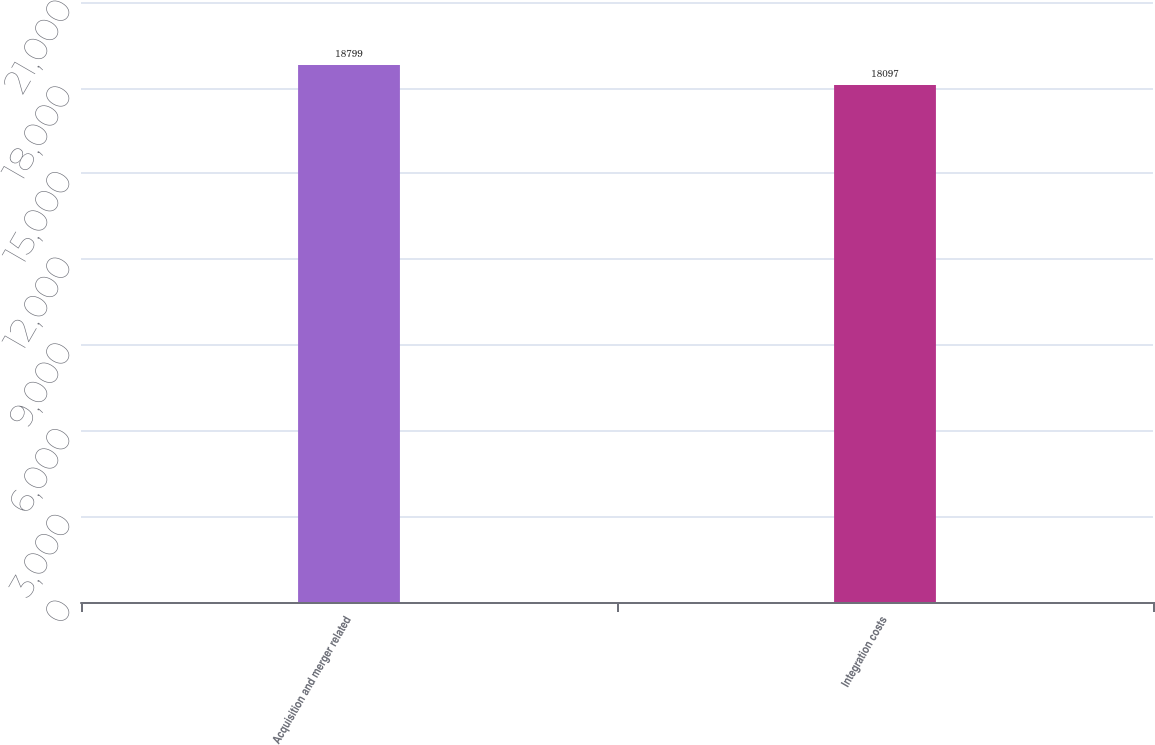Convert chart. <chart><loc_0><loc_0><loc_500><loc_500><bar_chart><fcel>Acquisition and merger related<fcel>Integration costs<nl><fcel>18799<fcel>18097<nl></chart> 